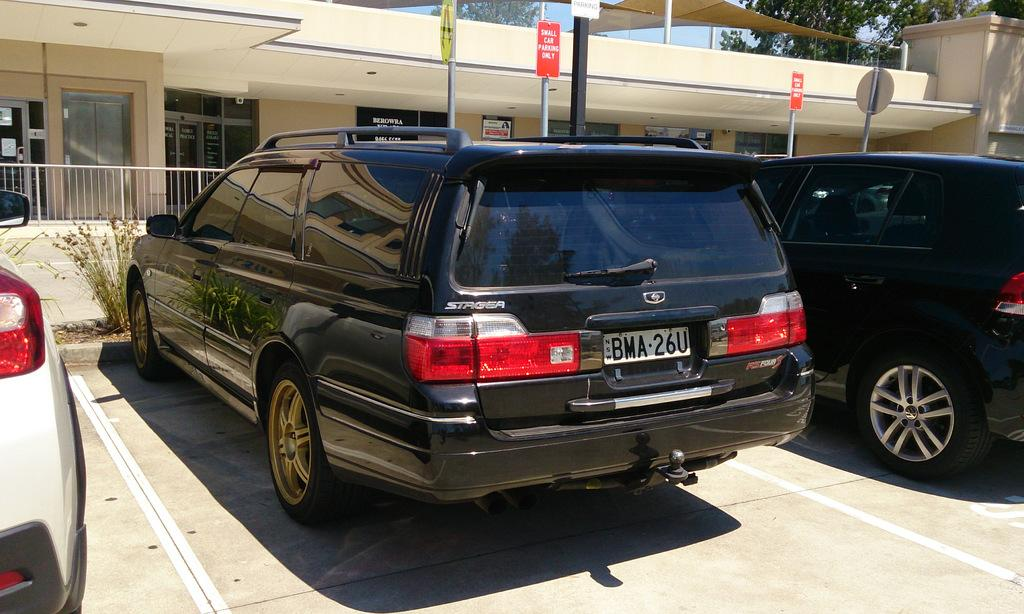What type of vehicles can be seen in the front of the image? There are cars in the front of the image. What is written on the boards in the background of the image? The provided facts do not mention the text on the boards, so we cannot answer this question definitively. What is located behind the cars in the image? There is a building and trees in the background of the image. What feature can be seen in the image that might be used for safety or support? There is a railing in the image. Where is the bed located in the image? There is no bed present in the image. What type of note is being passed between the cars in the image? There is no note being passed between the cars in the image. 